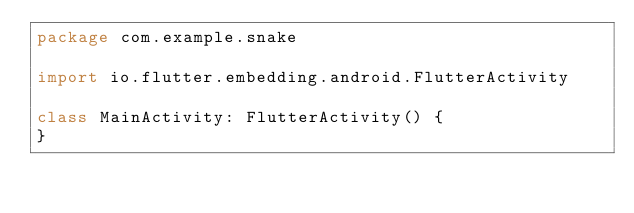<code> <loc_0><loc_0><loc_500><loc_500><_Kotlin_>package com.example.snake

import io.flutter.embedding.android.FlutterActivity

class MainActivity: FlutterActivity() {
}
</code> 